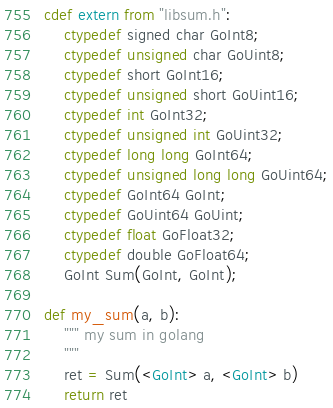<code> <loc_0><loc_0><loc_500><loc_500><_Cython_>

cdef extern from "libsum.h":
    ctypedef signed char GoInt8;
    ctypedef unsigned char GoUint8;
    ctypedef short GoInt16;
    ctypedef unsigned short GoUint16;
    ctypedef int GoInt32;
    ctypedef unsigned int GoUint32;
    ctypedef long long GoInt64;
    ctypedef unsigned long long GoUint64;
    ctypedef GoInt64 GoInt;
    ctypedef GoUint64 GoUint;
    ctypedef float GoFloat32;
    ctypedef double GoFloat64;
    GoInt Sum(GoInt, GoInt);
   
def my_sum(a, b):
    """ my sum in golang
    """
    ret = Sum(<GoInt> a, <GoInt> b)
    return ret
</code> 